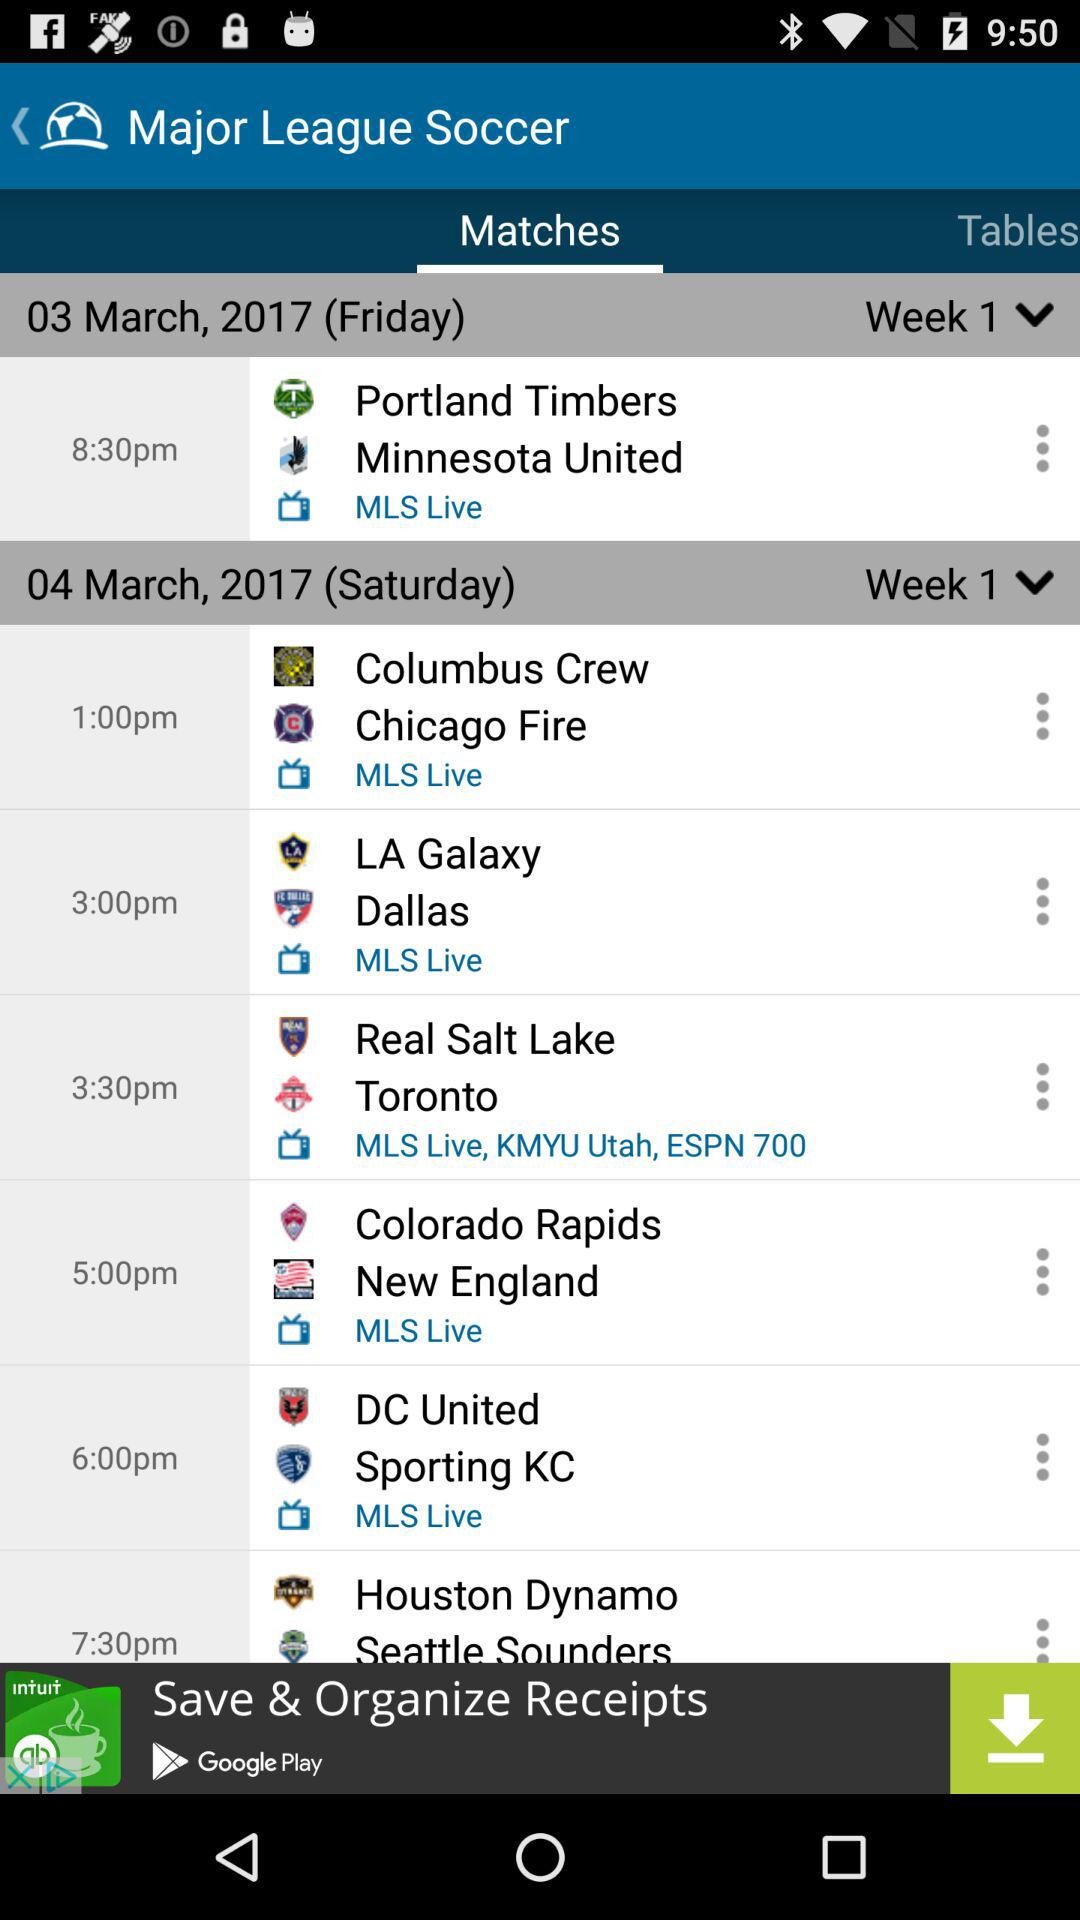What is the match timing of the LA Galaxy vs Dallas? The match time is 3 pm. 